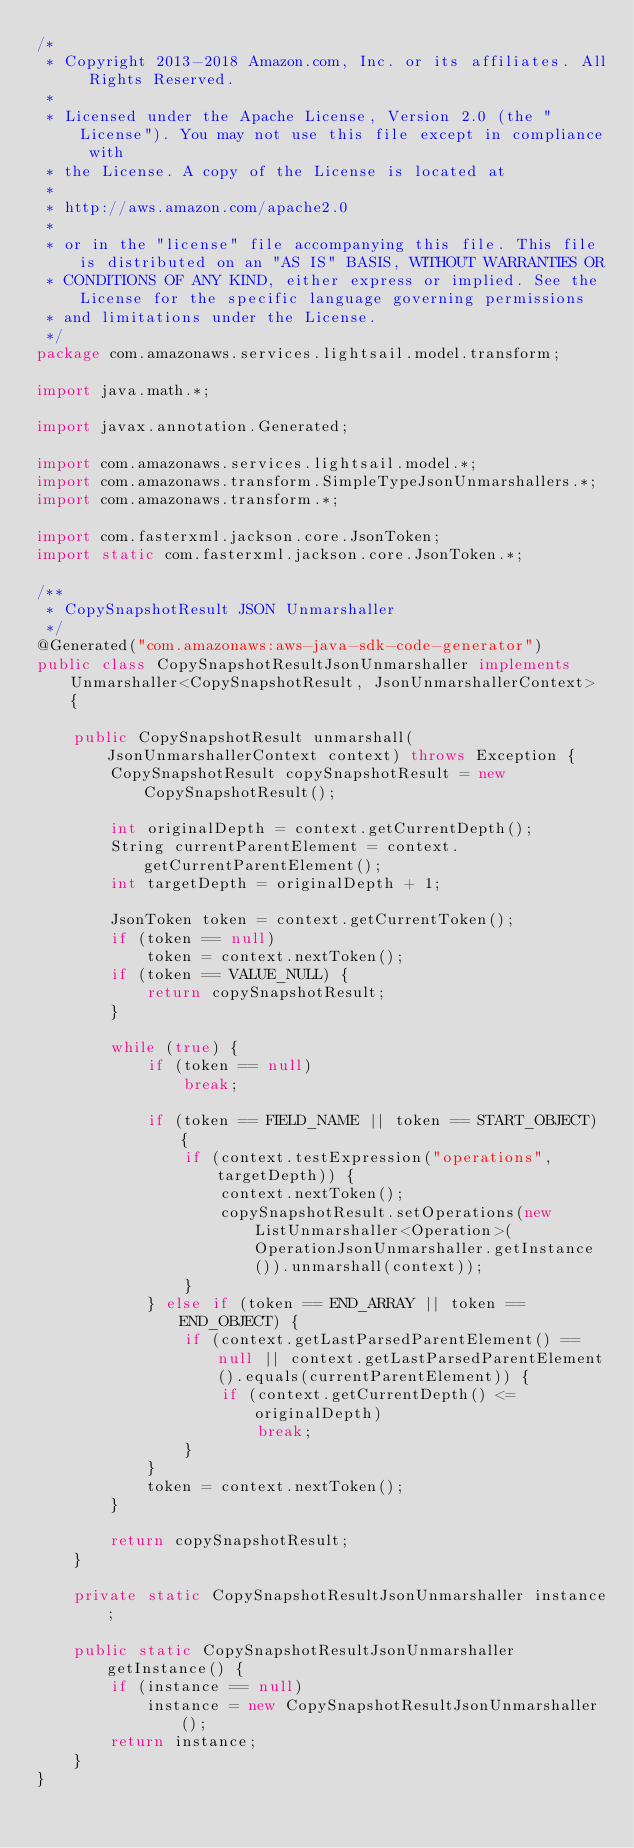<code> <loc_0><loc_0><loc_500><loc_500><_Java_>/*
 * Copyright 2013-2018 Amazon.com, Inc. or its affiliates. All Rights Reserved.
 * 
 * Licensed under the Apache License, Version 2.0 (the "License"). You may not use this file except in compliance with
 * the License. A copy of the License is located at
 * 
 * http://aws.amazon.com/apache2.0
 * 
 * or in the "license" file accompanying this file. This file is distributed on an "AS IS" BASIS, WITHOUT WARRANTIES OR
 * CONDITIONS OF ANY KIND, either express or implied. See the License for the specific language governing permissions
 * and limitations under the License.
 */
package com.amazonaws.services.lightsail.model.transform;

import java.math.*;

import javax.annotation.Generated;

import com.amazonaws.services.lightsail.model.*;
import com.amazonaws.transform.SimpleTypeJsonUnmarshallers.*;
import com.amazonaws.transform.*;

import com.fasterxml.jackson.core.JsonToken;
import static com.fasterxml.jackson.core.JsonToken.*;

/**
 * CopySnapshotResult JSON Unmarshaller
 */
@Generated("com.amazonaws:aws-java-sdk-code-generator")
public class CopySnapshotResultJsonUnmarshaller implements Unmarshaller<CopySnapshotResult, JsonUnmarshallerContext> {

    public CopySnapshotResult unmarshall(JsonUnmarshallerContext context) throws Exception {
        CopySnapshotResult copySnapshotResult = new CopySnapshotResult();

        int originalDepth = context.getCurrentDepth();
        String currentParentElement = context.getCurrentParentElement();
        int targetDepth = originalDepth + 1;

        JsonToken token = context.getCurrentToken();
        if (token == null)
            token = context.nextToken();
        if (token == VALUE_NULL) {
            return copySnapshotResult;
        }

        while (true) {
            if (token == null)
                break;

            if (token == FIELD_NAME || token == START_OBJECT) {
                if (context.testExpression("operations", targetDepth)) {
                    context.nextToken();
                    copySnapshotResult.setOperations(new ListUnmarshaller<Operation>(OperationJsonUnmarshaller.getInstance()).unmarshall(context));
                }
            } else if (token == END_ARRAY || token == END_OBJECT) {
                if (context.getLastParsedParentElement() == null || context.getLastParsedParentElement().equals(currentParentElement)) {
                    if (context.getCurrentDepth() <= originalDepth)
                        break;
                }
            }
            token = context.nextToken();
        }

        return copySnapshotResult;
    }

    private static CopySnapshotResultJsonUnmarshaller instance;

    public static CopySnapshotResultJsonUnmarshaller getInstance() {
        if (instance == null)
            instance = new CopySnapshotResultJsonUnmarshaller();
        return instance;
    }
}
</code> 